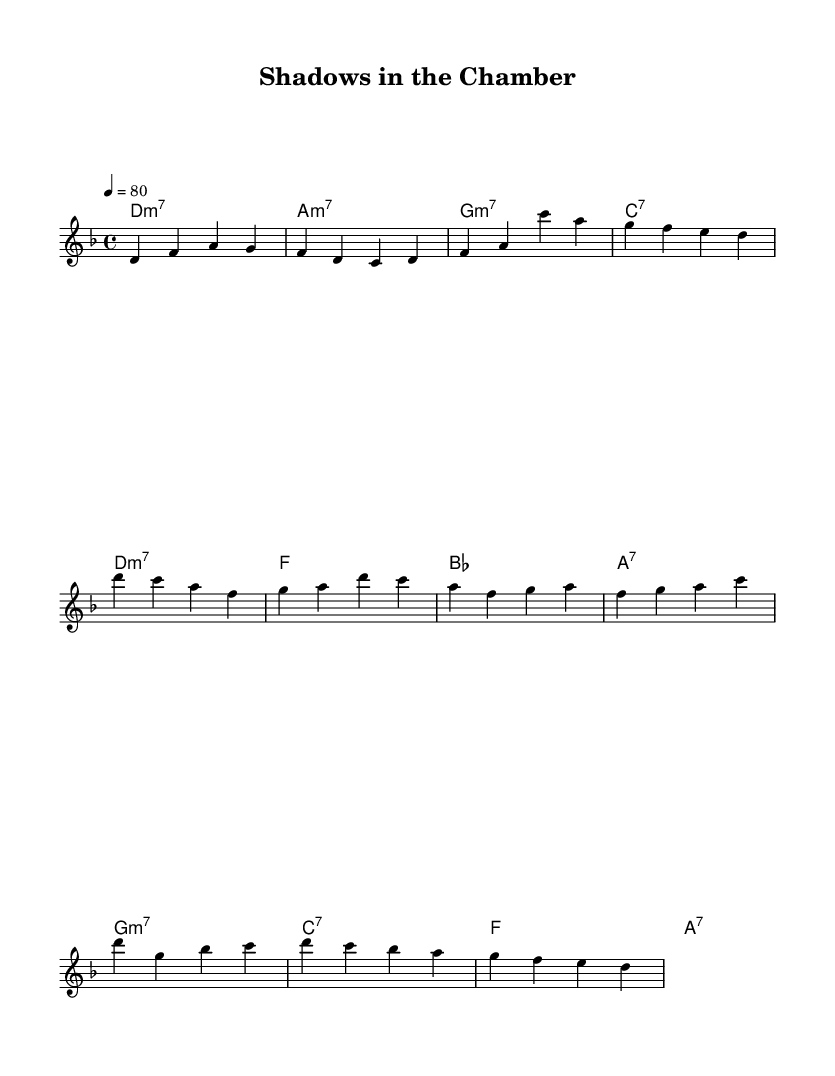What is the key signature of this music? The key signature is indicated by the sharp or flat symbols to the left of the staff, which, for this composition, shows one flat. This corresponds to the key of D minor.
Answer: D minor What is the time signature of this piece? The time signature is found at the beginning of the sheet music, represented as 4/4, indicating four beats per measure.
Answer: 4/4 What is the tempo marking for this composition? The tempo marking appears near the beginning of the music, indicating a speed of 80 beats per minute, which gives an idea of how fast the music should be played.
Answer: 80 How many measures are in the verse section? By visually counting the grouped notes in the verse section, there are four measures, each consisting of four beats, leading to a total of 16 beats.
Answer: Four What is the chord used in the bridge section? To determine the chord in the bridge, we analyze the chord symbols written above the staff, which indicate a G minor seventh chord.
Answer: G minor seventh In which section does the chorus begin? Observing the structure of the piece, the chorus begins after the verse, marked by a shift in the melody and the chord progression as indicated above the staff.
Answer: After the verse What musical elements contribute to the neo-soul feel in this piece? The composition uses extended harmonies (such as minor and dominant seventh chords), syncopated rhythms, and an expressive melody, all key characteristics of neo-soul music.
Answer: Extended harmonies, syncopation, expressive melody 